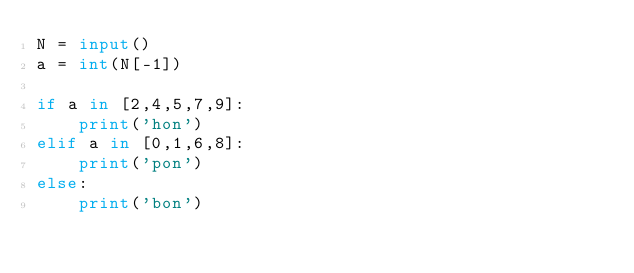Convert code to text. <code><loc_0><loc_0><loc_500><loc_500><_Python_>N = input()
a = int(N[-1])

if a in [2,4,5,7,9]:
    print('hon')
elif a in [0,1,6,8]:
    print('pon')
else:
    print('bon')</code> 